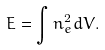<formula> <loc_0><loc_0><loc_500><loc_500>E = \int n _ { e } ^ { 2 } d V .</formula> 